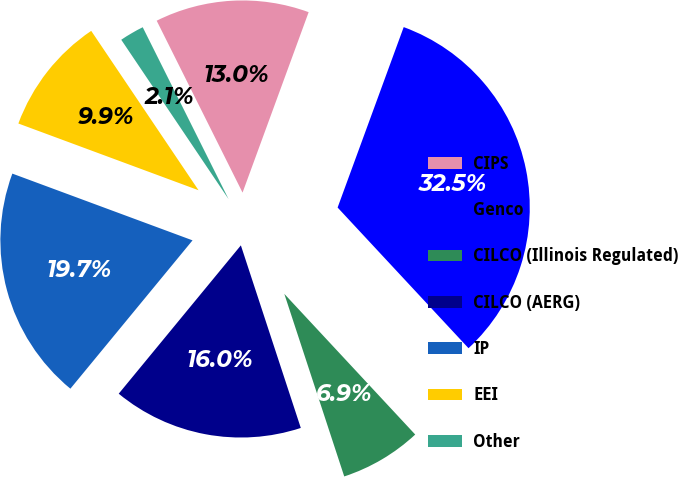Convert chart. <chart><loc_0><loc_0><loc_500><loc_500><pie_chart><fcel>CIPS<fcel>Genco<fcel>CILCO (Illinois Regulated)<fcel>CILCO (AERG)<fcel>IP<fcel>EEI<fcel>Other<nl><fcel>12.96%<fcel>32.48%<fcel>6.88%<fcel>16.01%<fcel>19.68%<fcel>9.92%<fcel>2.06%<nl></chart> 